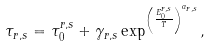Convert formula to latex. <formula><loc_0><loc_0><loc_500><loc_500>\tau _ { r , s } = \tau _ { 0 } ^ { r , s } + \gamma _ { r , s } \exp ^ { \left ( \frac { E _ { 0 } ^ { r , s } } { T } \right ) ^ { a _ { r , s } } } ,</formula> 